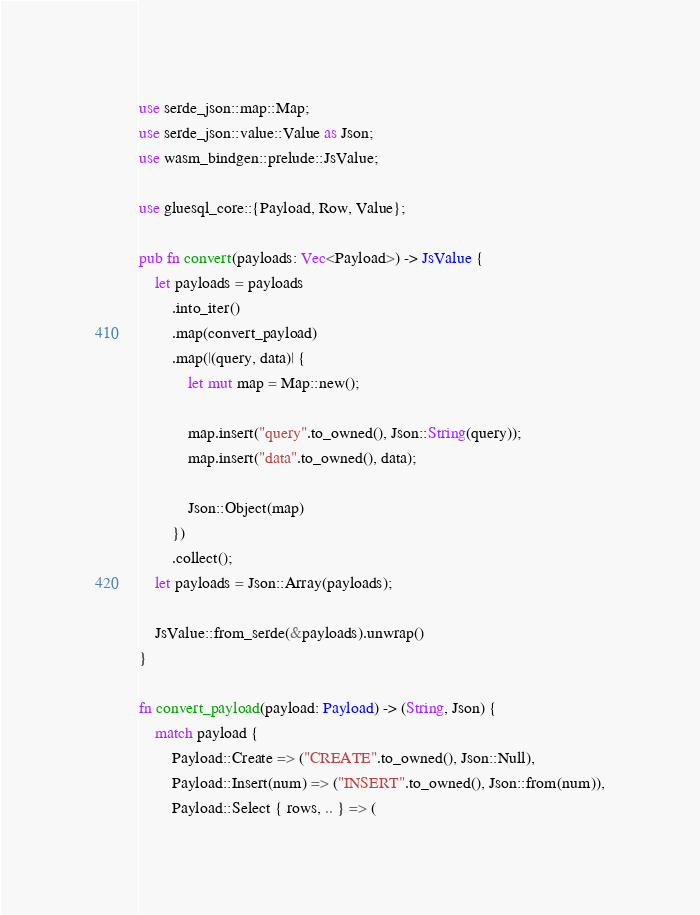Convert code to text. <code><loc_0><loc_0><loc_500><loc_500><_Rust_>use serde_json::map::Map;
use serde_json::value::Value as Json;
use wasm_bindgen::prelude::JsValue;

use gluesql_core::{Payload, Row, Value};

pub fn convert(payloads: Vec<Payload>) -> JsValue {
    let payloads = payloads
        .into_iter()
        .map(convert_payload)
        .map(|(query, data)| {
            let mut map = Map::new();

            map.insert("query".to_owned(), Json::String(query));
            map.insert("data".to_owned(), data);

            Json::Object(map)
        })
        .collect();
    let payloads = Json::Array(payloads);

    JsValue::from_serde(&payloads).unwrap()
}

fn convert_payload(payload: Payload) -> (String, Json) {
    match payload {
        Payload::Create => ("CREATE".to_owned(), Json::Null),
        Payload::Insert(num) => ("INSERT".to_owned(), Json::from(num)),
        Payload::Select { rows, .. } => (</code> 